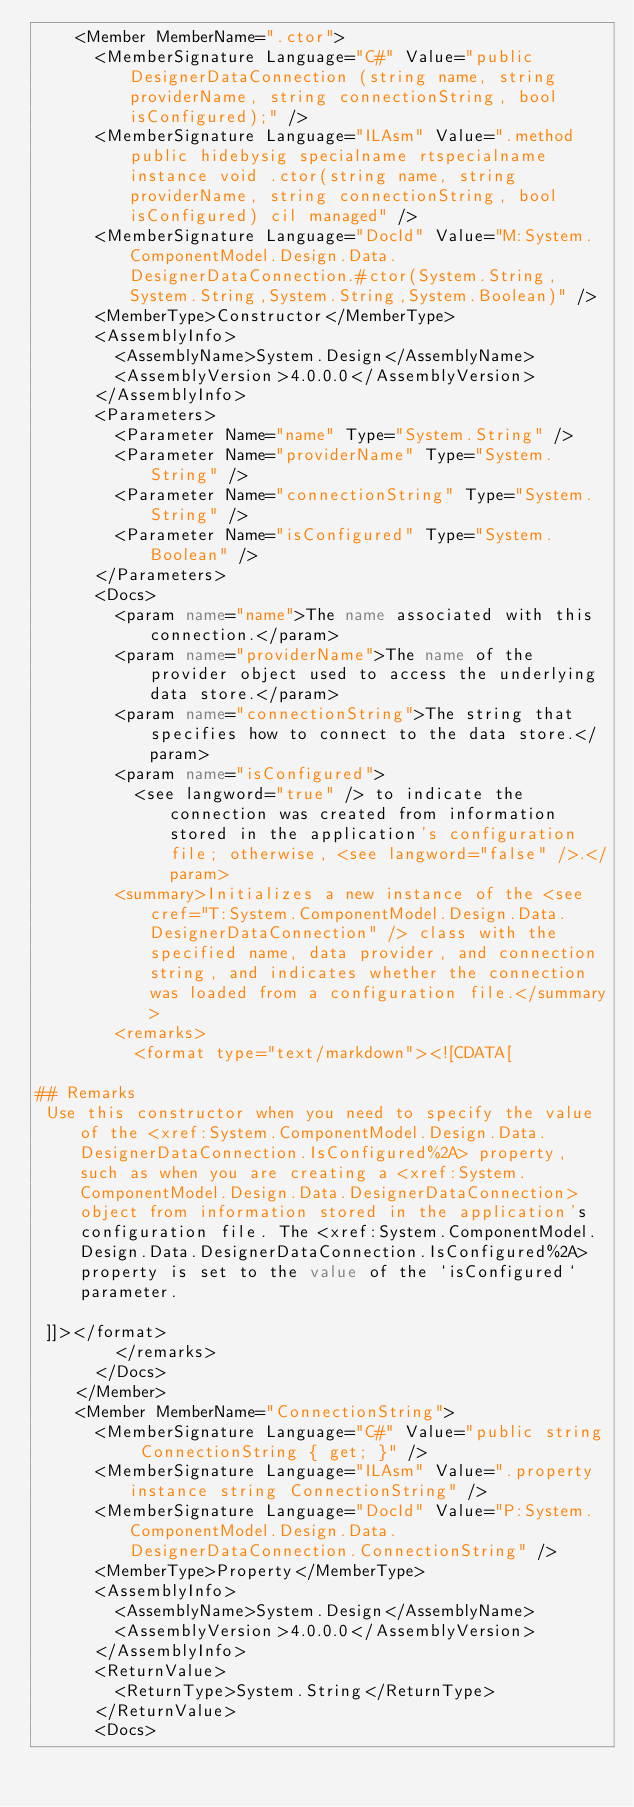Convert code to text. <code><loc_0><loc_0><loc_500><loc_500><_XML_>    <Member MemberName=".ctor">
      <MemberSignature Language="C#" Value="public DesignerDataConnection (string name, string providerName, string connectionString, bool isConfigured);" />
      <MemberSignature Language="ILAsm" Value=".method public hidebysig specialname rtspecialname instance void .ctor(string name, string providerName, string connectionString, bool isConfigured) cil managed" />
      <MemberSignature Language="DocId" Value="M:System.ComponentModel.Design.Data.DesignerDataConnection.#ctor(System.String,System.String,System.String,System.Boolean)" />
      <MemberType>Constructor</MemberType>
      <AssemblyInfo>
        <AssemblyName>System.Design</AssemblyName>
        <AssemblyVersion>4.0.0.0</AssemblyVersion>
      </AssemblyInfo>
      <Parameters>
        <Parameter Name="name" Type="System.String" />
        <Parameter Name="providerName" Type="System.String" />
        <Parameter Name="connectionString" Type="System.String" />
        <Parameter Name="isConfigured" Type="System.Boolean" />
      </Parameters>
      <Docs>
        <param name="name">The name associated with this connection.</param>
        <param name="providerName">The name of the provider object used to access the underlying data store.</param>
        <param name="connectionString">The string that specifies how to connect to the data store.</param>
        <param name="isConfigured">
          <see langword="true" /> to indicate the connection was created from information stored in the application's configuration file; otherwise, <see langword="false" />.</param>
        <summary>Initializes a new instance of the <see cref="T:System.ComponentModel.Design.Data.DesignerDataConnection" /> class with the specified name, data provider, and connection string, and indicates whether the connection was loaded from a configuration file.</summary>
        <remarks>
          <format type="text/markdown"><![CDATA[  
  
## Remarks  
 Use this constructor when you need to specify the value of the <xref:System.ComponentModel.Design.Data.DesignerDataConnection.IsConfigured%2A> property, such as when you are creating a <xref:System.ComponentModel.Design.Data.DesignerDataConnection> object from information stored in the application's configuration file. The <xref:System.ComponentModel.Design.Data.DesignerDataConnection.IsConfigured%2A> property is set to the value of the `isConfigured` parameter.  
  
 ]]></format>
        </remarks>
      </Docs>
    </Member>
    <Member MemberName="ConnectionString">
      <MemberSignature Language="C#" Value="public string ConnectionString { get; }" />
      <MemberSignature Language="ILAsm" Value=".property instance string ConnectionString" />
      <MemberSignature Language="DocId" Value="P:System.ComponentModel.Design.Data.DesignerDataConnection.ConnectionString" />
      <MemberType>Property</MemberType>
      <AssemblyInfo>
        <AssemblyName>System.Design</AssemblyName>
        <AssemblyVersion>4.0.0.0</AssemblyVersion>
      </AssemblyInfo>
      <ReturnValue>
        <ReturnType>System.String</ReturnType>
      </ReturnValue>
      <Docs></code> 